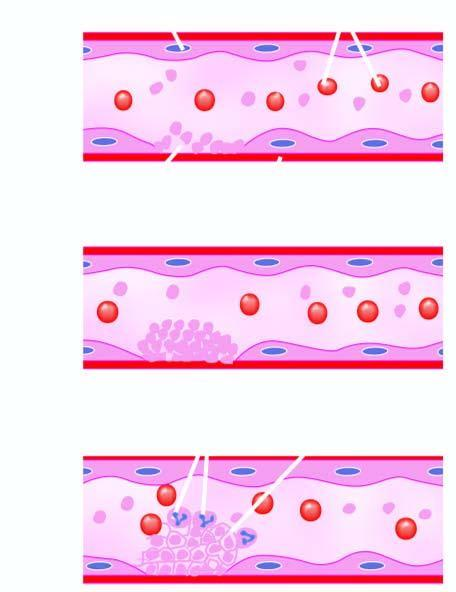what is released?
Answer the question using a single word or phrase. Adp 